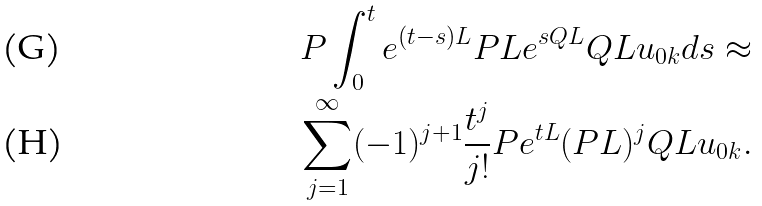Convert formula to latex. <formula><loc_0><loc_0><loc_500><loc_500>P \int _ { 0 } ^ { t } e ^ { ( t - s ) L } P L e ^ { s Q L } Q L u _ { 0 k } d s \approx \\ \sum _ { j = 1 } ^ { \infty } ( - 1 ) ^ { j + 1 } \frac { t ^ { j } } { j ! } P e ^ { t L } ( P L ) ^ { j } Q L u _ { 0 k } .</formula> 